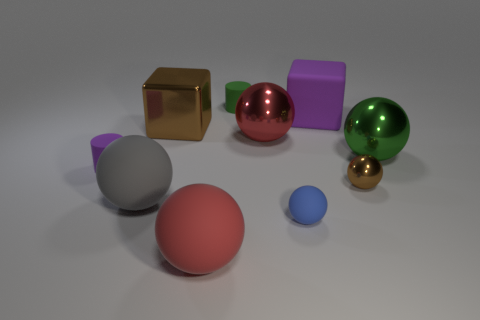Is the number of rubber objects that are in front of the large brown shiny block greater than the number of big purple rubber blocks?
Provide a short and direct response. Yes. There is a green object behind the big red ball to the right of the red object that is in front of the brown metal sphere; what shape is it?
Make the answer very short. Cylinder. Do the cube on the right side of the blue rubber sphere and the large brown shiny object have the same size?
Offer a terse response. Yes. The matte thing that is both in front of the green rubber object and behind the tiny purple object has what shape?
Your answer should be very brief. Cube. Is the color of the large shiny cube the same as the metal sphere that is in front of the small purple thing?
Make the answer very short. Yes. What color is the large block to the left of the tiny sphere left of the purple rubber thing on the right side of the tiny green object?
Ensure brevity in your answer.  Brown. The other small thing that is the same shape as the small green thing is what color?
Keep it short and to the point. Purple. Is the number of large rubber balls that are in front of the red matte thing the same as the number of large yellow blocks?
Make the answer very short. Yes. How many cylinders are either metal things or gray objects?
Keep it short and to the point. 0. What color is the tiny cylinder that is the same material as the tiny purple thing?
Offer a terse response. Green. 